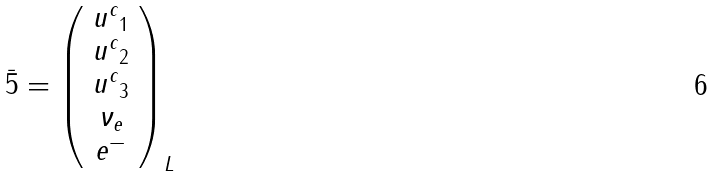Convert formula to latex. <formula><loc_0><loc_0><loc_500><loc_500>\bar { 5 } = { \left ( \begin{array} { c } { u ^ { c } } _ { 1 } \\ { u ^ { c } } _ { 2 } \\ { u ^ { c } } _ { 3 } \\ { \nu } _ { e } \\ e ^ { - } \end{array} \right ) } _ { L }</formula> 